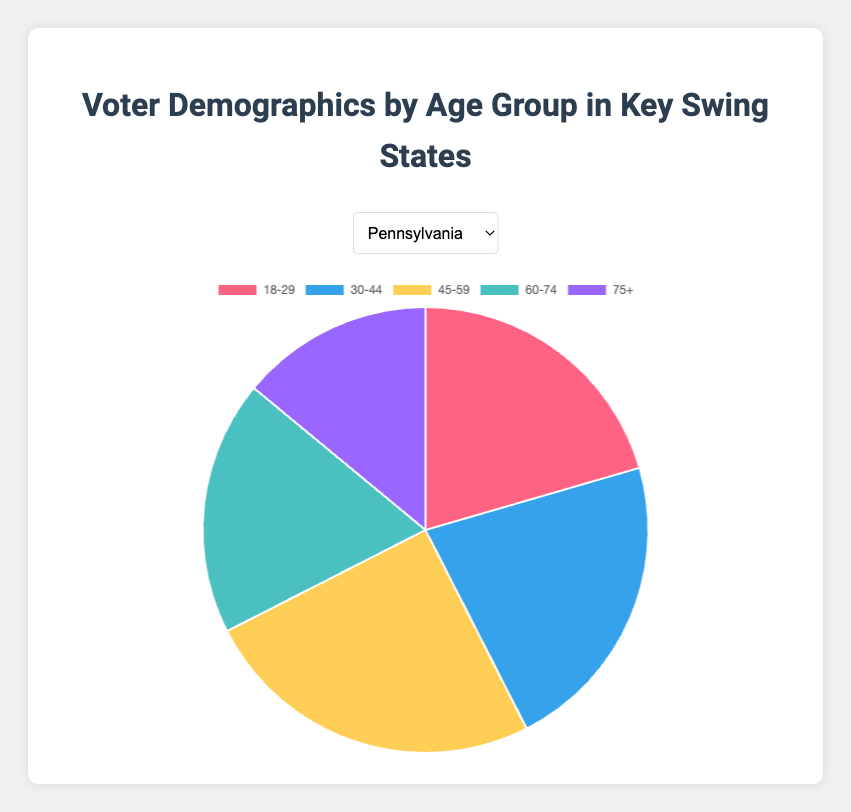Which age group has the highest percentage of voters in Pennsylvania? Find the slice with the largest percentage in the Pennsylvania pie chart. The "45-59" age group has the highest percentage at 25.0%.
Answer: 45-59 Which state has the lowest percentage of voters in the "30-44" age group? Compare the percentages of the "30-44" age group across all states. Wisconsin has the lowest percentage at 20.1%.
Answer: Wisconsin What is the average percentage of voters in the "75+" age group across all states? Add the percentages of the "75+" age group for all states (14.0 + 14.8 + 15.6 + 13.4 + 15.2 = 73), then divide by the number of states (5). The average is 73 / 5 = 14.6%.
Answer: 14.6% Compare the percentage of voters aged 60-74 between Wisconsin and North Carolina. Which state has a higher share? Check the pie chart percentages for the 60-74 age group in each state. Wisconsin has 21.0%, while North Carolina has 18.1%. Wisconsin has a higher share.
Answer: Wisconsin For Arizona, which age group has the second-highest percentage of voters? Identify the second-largest slice in the Arizona pie chart. The "30-44" age group (25.1%) is the highest, followed by "18-29" at 23.4%.
Answer: 18-29 What is the combined percentage of voters aged 18-29 and 30-44 in Michigan? Sum the percentages of the "18-29" and "30-44" age groups in Michigan: 18.6% + 21.7% = 40.3%.
Answer: 40.3% Is the percentage of voters in the "45-59" age group in North Carolina higher or lower than in Wisconsin? Compare the percentages of the "45-59" age group in both states. North Carolina has 22.5%, while Wisconsin has 25.5%. North Carolina's percentage is lower.
Answer: Lower Which state has the highest percentage of voters aged 18-29? Check which state has the largest percentage for the 18-29 age group. Arizona has the highest at 23.4%.
Answer: Arizona In Pennsylvania, what is the difference in percentage between the "30-44" and "75+" age groups? Subtract the percentage of the "75+" age group from the "30-44" age group in Pennsylvania: 22.0% - 14.0% = 8.0%.
Answer: 8.0% 